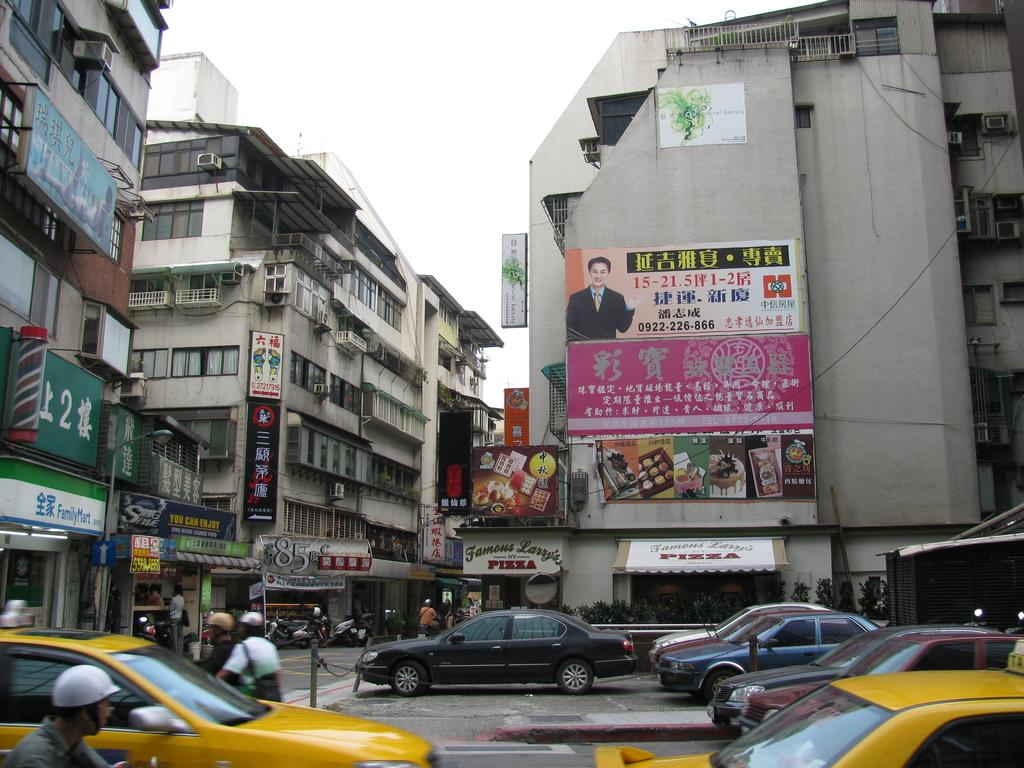<image>
Render a clear and concise summary of the photo. A sign over the door tells you the restaurant is Famous Larry's NY Pizza 